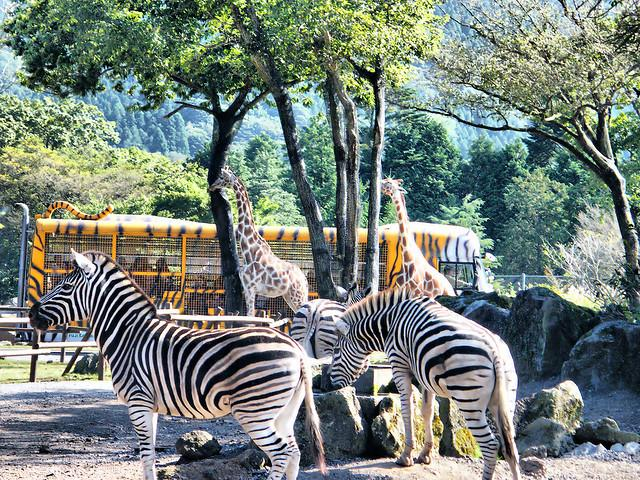What kind of vehicle is the yellow thing? bus 